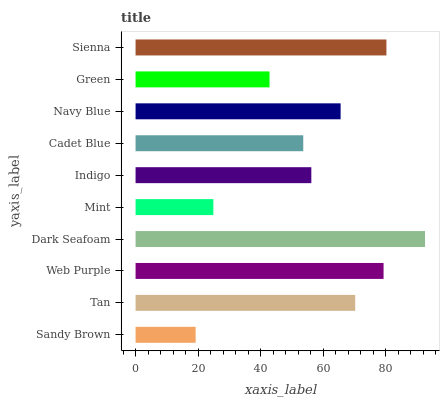Is Sandy Brown the minimum?
Answer yes or no. Yes. Is Dark Seafoam the maximum?
Answer yes or no. Yes. Is Tan the minimum?
Answer yes or no. No. Is Tan the maximum?
Answer yes or no. No. Is Tan greater than Sandy Brown?
Answer yes or no. Yes. Is Sandy Brown less than Tan?
Answer yes or no. Yes. Is Sandy Brown greater than Tan?
Answer yes or no. No. Is Tan less than Sandy Brown?
Answer yes or no. No. Is Navy Blue the high median?
Answer yes or no. Yes. Is Indigo the low median?
Answer yes or no. Yes. Is Indigo the high median?
Answer yes or no. No. Is Web Purple the low median?
Answer yes or no. No. 